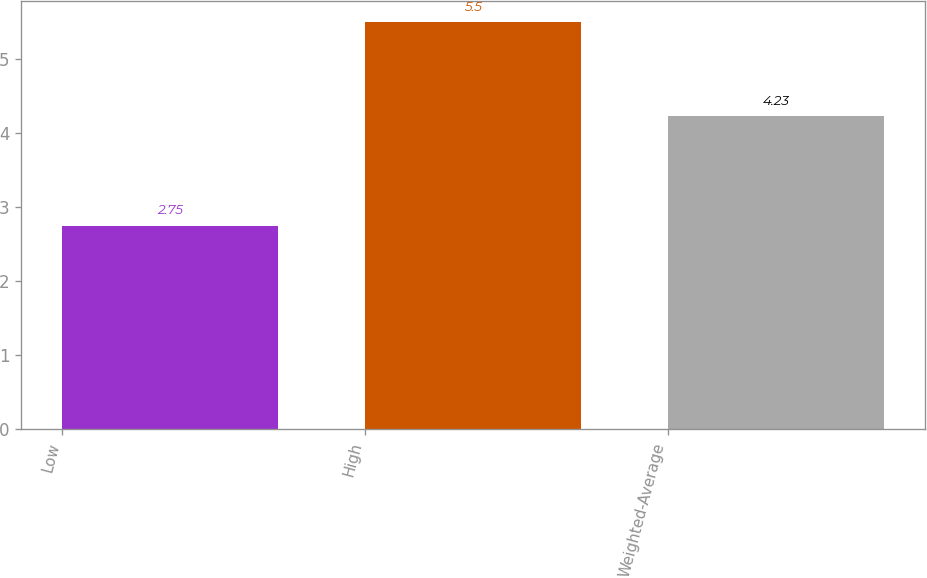Convert chart to OTSL. <chart><loc_0><loc_0><loc_500><loc_500><bar_chart><fcel>Low<fcel>High<fcel>Weighted-Average<nl><fcel>2.75<fcel>5.5<fcel>4.23<nl></chart> 